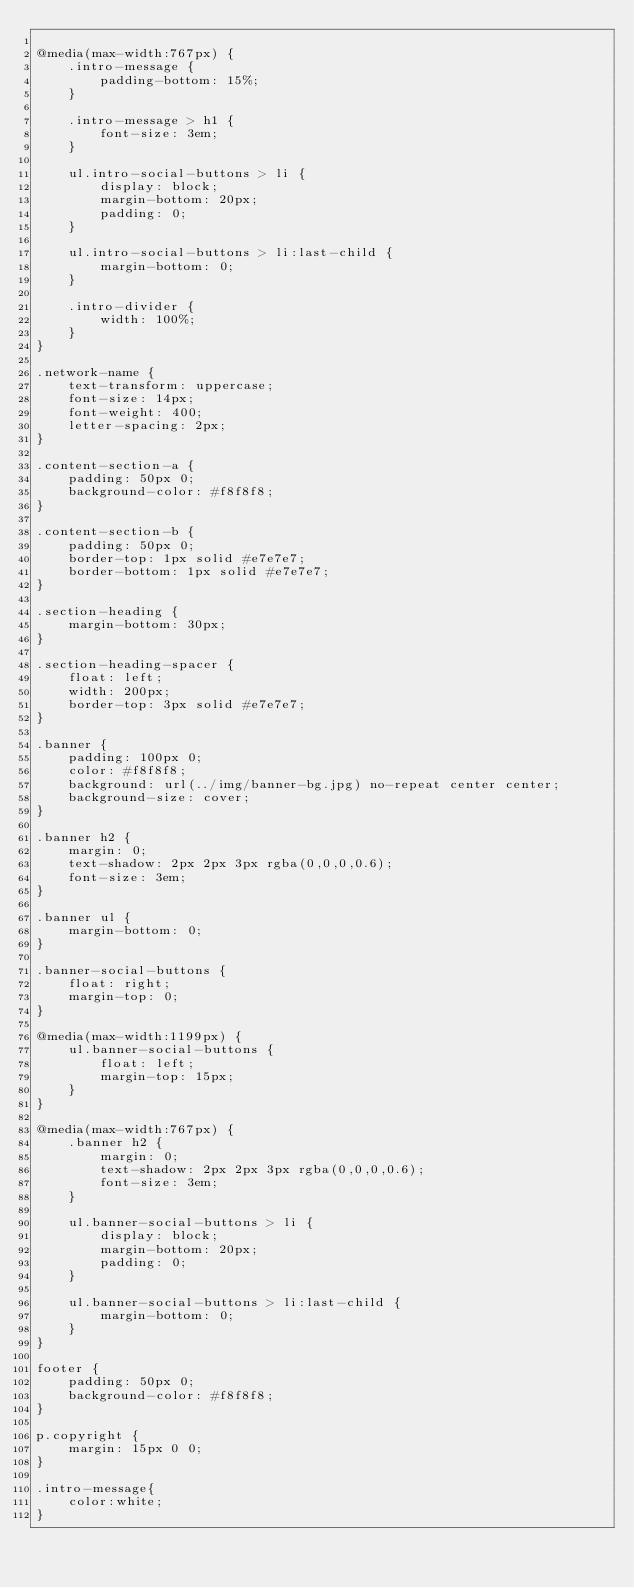<code> <loc_0><loc_0><loc_500><loc_500><_CSS_>
@media(max-width:767px) {
    .intro-message {
        padding-bottom: 15%;
    }

    .intro-message > h1 {
        font-size: 3em;
    }

    ul.intro-social-buttons > li {
        display: block;
        margin-bottom: 20px;
        padding: 0;
    }

    ul.intro-social-buttons > li:last-child {
        margin-bottom: 0;
    }

    .intro-divider {
        width: 100%;
    }
}

.network-name {
    text-transform: uppercase;
    font-size: 14px;
    font-weight: 400;
    letter-spacing: 2px;
}

.content-section-a {
    padding: 50px 0;
    background-color: #f8f8f8;
}

.content-section-b {
    padding: 50px 0;
    border-top: 1px solid #e7e7e7;
    border-bottom: 1px solid #e7e7e7;
}

.section-heading {
    margin-bottom: 30px;
}

.section-heading-spacer {
    float: left;
    width: 200px;
    border-top: 3px solid #e7e7e7;
}

.banner {
    padding: 100px 0;
    color: #f8f8f8;
    background: url(../img/banner-bg.jpg) no-repeat center center;
    background-size: cover;
}

.banner h2 {
    margin: 0;
    text-shadow: 2px 2px 3px rgba(0,0,0,0.6);
    font-size: 3em;
}

.banner ul {
    margin-bottom: 0;
}

.banner-social-buttons {
    float: right;
    margin-top: 0;
}

@media(max-width:1199px) {
    ul.banner-social-buttons {
        float: left;
        margin-top: 15px;
    }
}

@media(max-width:767px) {
    .banner h2 {
        margin: 0;
        text-shadow: 2px 2px 3px rgba(0,0,0,0.6);
        font-size: 3em;
    }

    ul.banner-social-buttons > li {
        display: block;
        margin-bottom: 20px;
        padding: 0;
    }

    ul.banner-social-buttons > li:last-child {
        margin-bottom: 0;
    }
}

footer {
    padding: 50px 0;
    background-color: #f8f8f8;
}

p.copyright {
    margin: 15px 0 0;
}

.intro-message{
    color:white;
}

</code> 